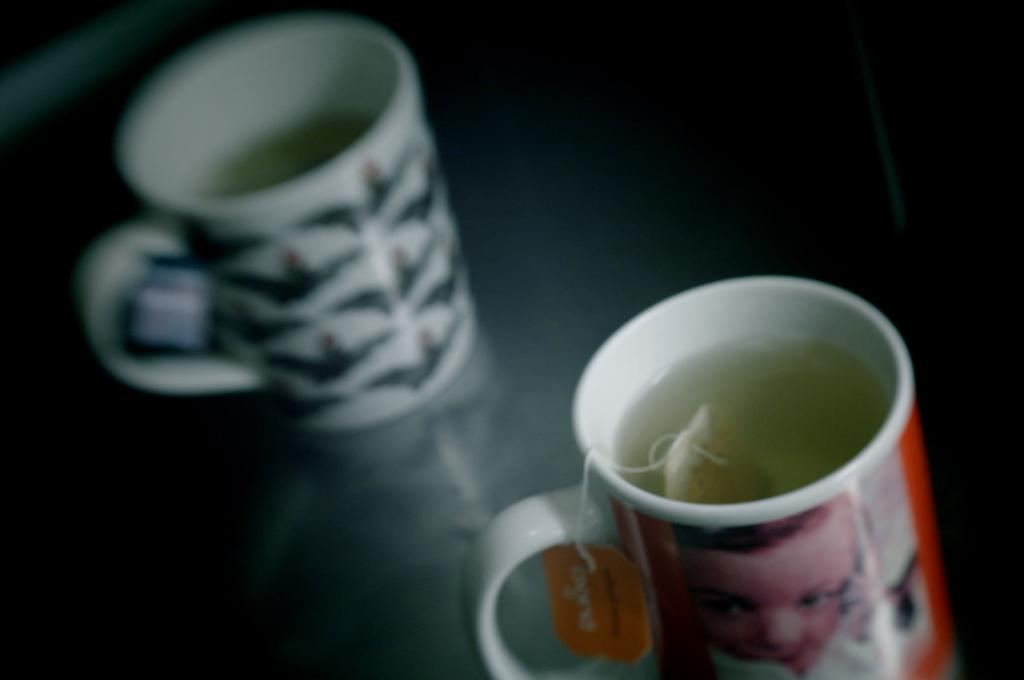Where was the image taken? The image was taken indoors. What furniture is visible in the image? There is a table in the image. What beverages are on the table? There are two cups of tea on the table. How many girls are sneezing in the image? There are no girls present in the image, and therefore no one is sneezing. How much sugar is in the tea in the image? The image does not provide information about the amount of sugar in the tea, only that there are two cups of tea on the table. 